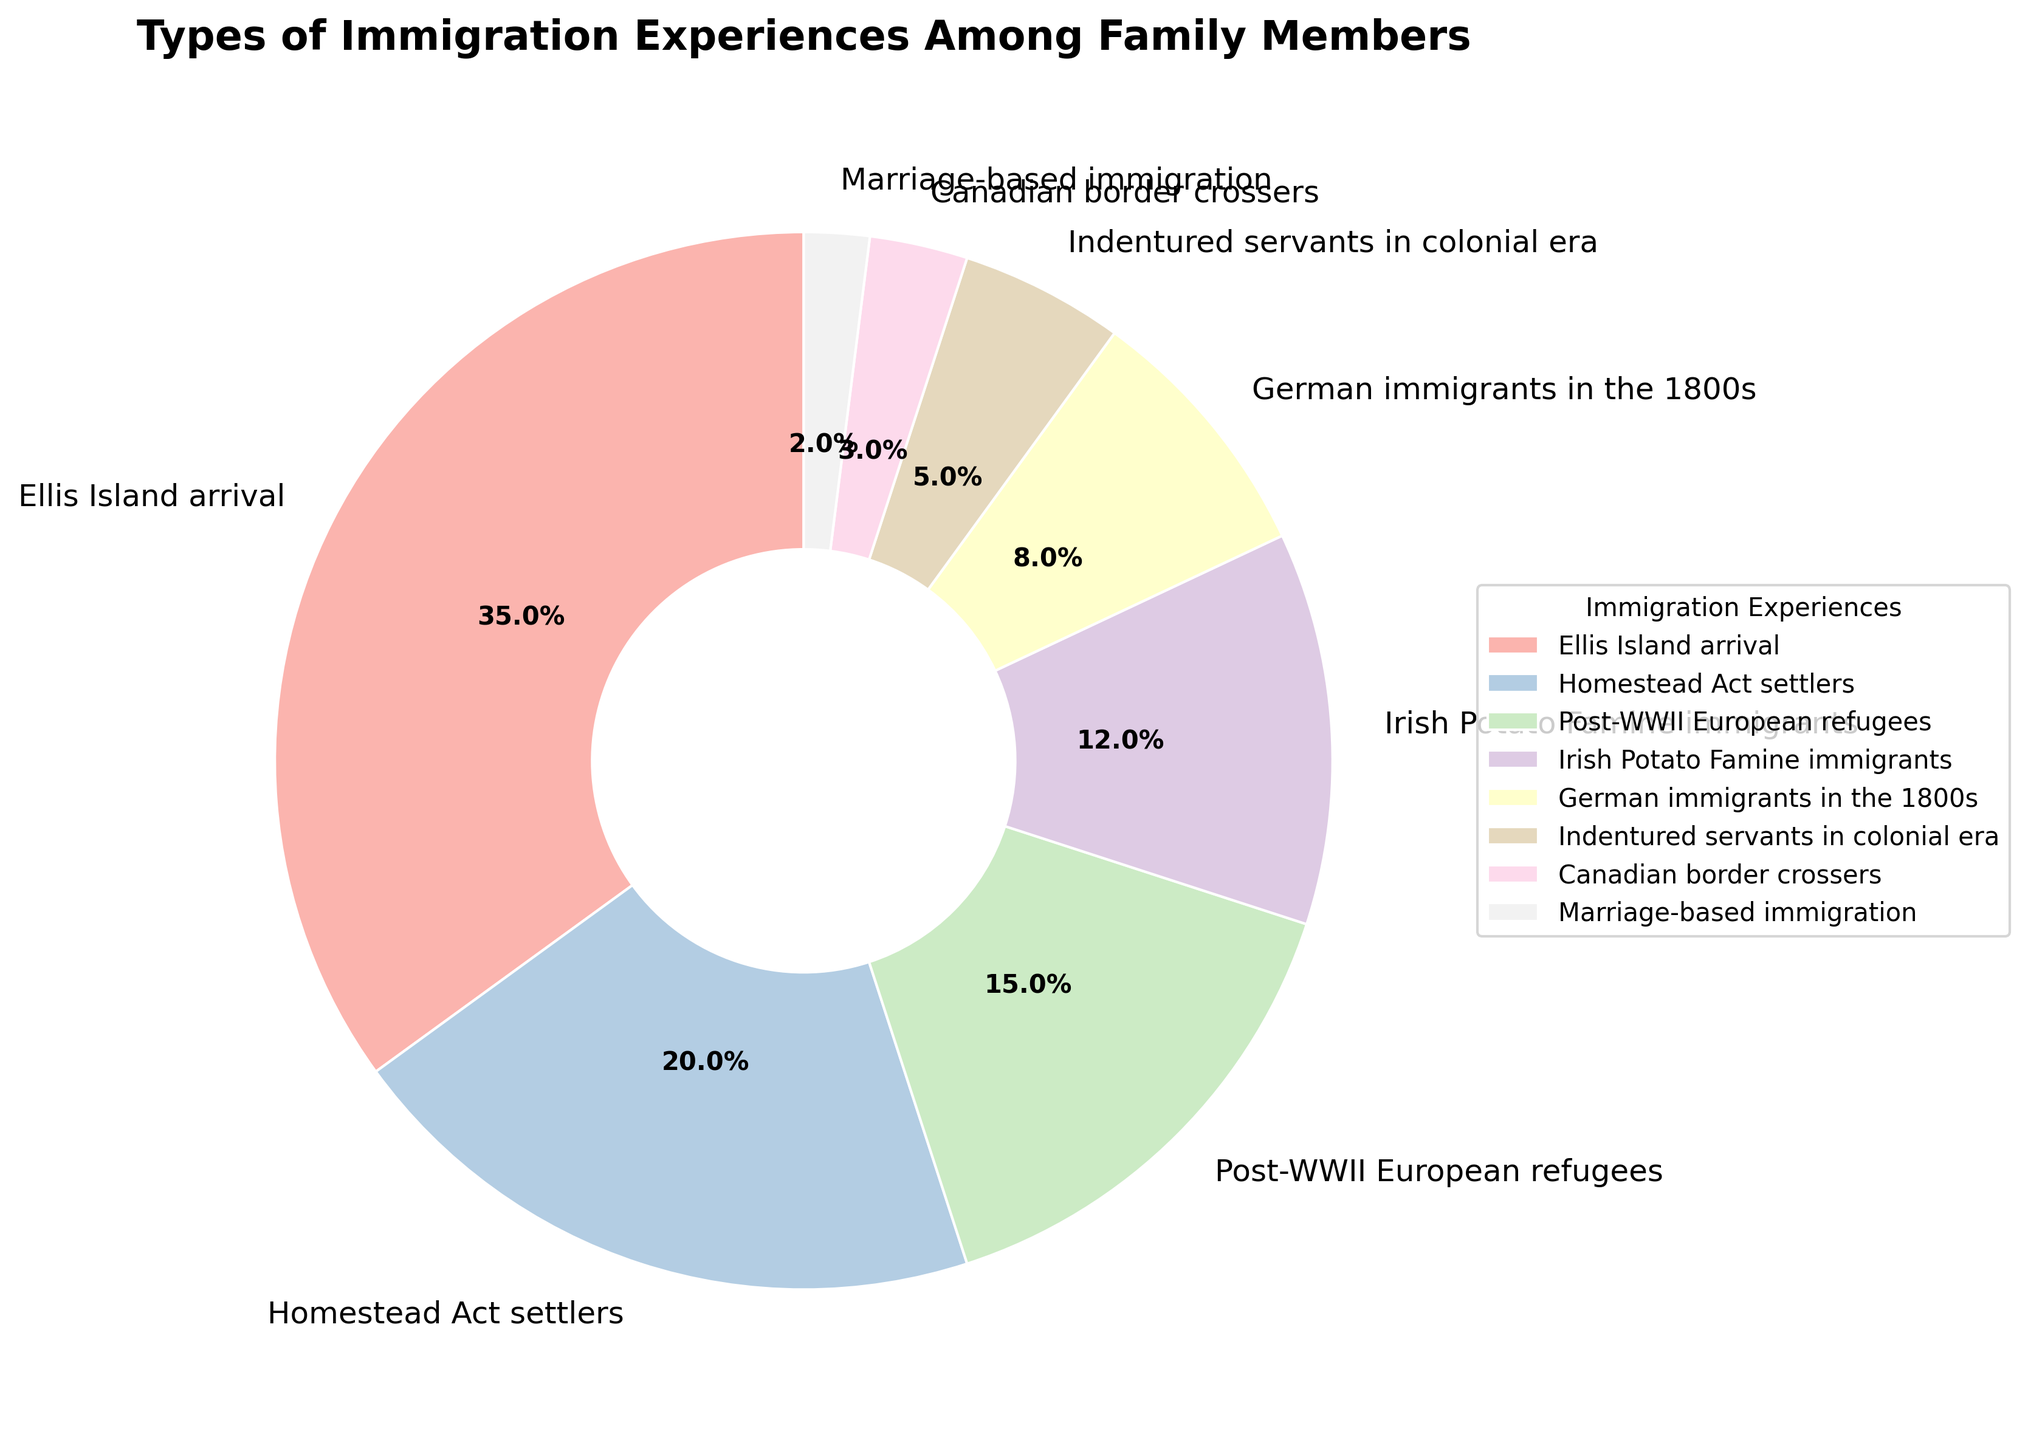Which immigration experience is the most common among family members? The figure shows the percentages of different types of immigration experiences. The largest wedge represents "Ellis Island arrival" at 35%.
Answer: Ellis Island arrival Which immigration experience is the least common among family members? The smallest wedge section in the pie chart corresponds to "Marriage-based immigration" at 2%.
Answer: Marriage-based immigration What is the combined percentage of "Homestead Act settlers" and "Post-WWII European refugees"? Add the individual percentages: Homestead Act settlers (20%) + Post-WWII European refugees (15%) = 35%.
Answer: 35% Are there more "Irish Potato Famine immigrants" or "German immigrants in the 1800s"? The chart indicates that Irish Potato Famine immigrants account for 12%, whereas German immigrants in the 1800s account for 8%. Thus, Irish Potato Famine immigrants are more.
Answer: Irish Potato Famine immigrants What color is used to represent "Canadian border crossers"? In the chart, identify the wedge corresponding to "Canadian border crossers" and note its color, which comes from the Pastel1 color palette.
Answer: Light green (or corresponding palette color) How does the percentage of "Indentured servants in colonial era" compare to that of "Homestead Act settlers"? Indentured servants in colonial era make up 5% of the chart, while Homestead Act settlers make up 20%. The percentage for Homestead Act settlers is greater.
Answer: Homestead Act settlers What is the ratio of "Ellis Island arrival" experiences to "Marriage-based immigration" experiences? Ratio can be calculated by dividing their percentages: 35% / 2% = 17.5.
Answer: 17.5 If you sum up the percentages of all experiences that took place in the 1800s, what do you get? Combine the percentages for "Homestead Act settlers" (20%) and "German immigrants in the 1800s" (8%): 20% + 8% = 28%.
Answer: 28% 